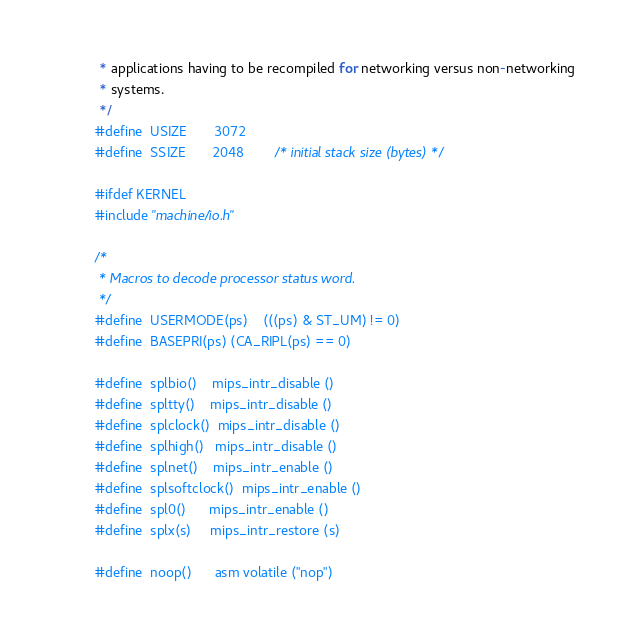<code> <loc_0><loc_0><loc_500><loc_500><_C_> * applications having to be recompiled for networking versus non-networking
 * systems.
 */
#define	USIZE		3072
#define	SSIZE		2048		/* initial stack size (bytes) */

#ifdef KERNEL
#include "machine/io.h"

/*
 * Macros to decode processor status word.
 */
#define	USERMODE(ps)	(((ps) & ST_UM) != 0)
#define	BASEPRI(ps)	(CA_RIPL(ps) == 0)

#define	splbio()	mips_intr_disable ()
#define	spltty()	mips_intr_disable ()
#define	splclock()	mips_intr_disable ()
#define	splhigh()	mips_intr_disable ()
#define	splnet()	mips_intr_enable ()
#define	splsoftclock()	mips_intr_enable ()
#define	spl0()		mips_intr_enable ()
#define	splx(s)		mips_intr_restore (s)

#define	noop()		asm volatile ("nop")</code> 